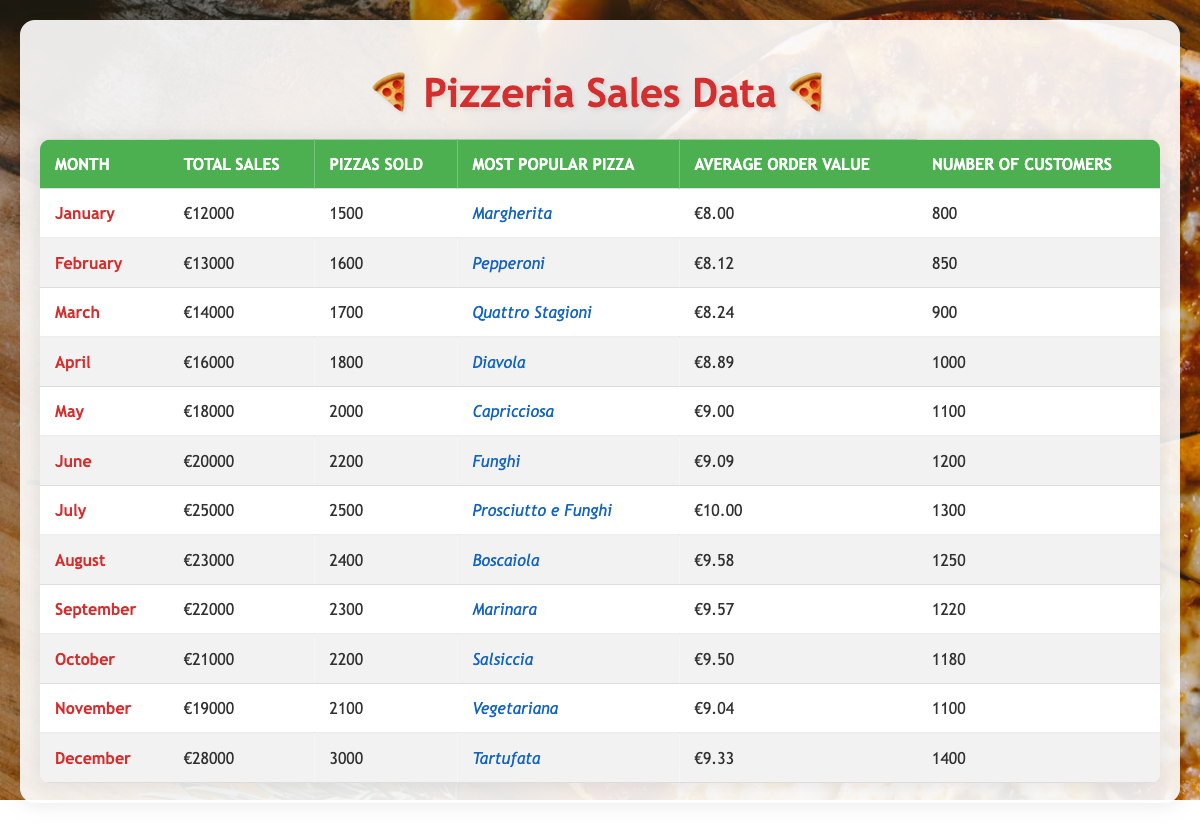What was the total sales in December? The table shows a total sales value of €28,000 for December.
Answer: 28000 Which month had the highest number of pizzas sold? In July, the number of pizzas sold was 2,500, which is the highest compared to other months displayed in the table.
Answer: July What was the average order value in May? The average order value for May is listed as €9.00 in the table.
Answer: 9.00 Is the most popular pizza in January "Margherita"? The table indicates that the most popular pizza sold in January is indeed "Margherita."
Answer: Yes What was the total sales difference between June and July? The total sales in June was €20,000, and in July it was €25,000. The difference is €25,000 - €20,000 = €5,000.
Answer: 5000 Which pizza was the most popular in March and what was its average order value? The most popular pizza in March was "Quattro Stagioni," and its average order value was €8.24, as seen in the table.
Answer: Quattro Stagioni, 8.24 If we average the number of customers from January to March, what would it be? The number of customers from January (800), February (850), and March (900) totals 800 + 850 + 900 = 2550. Dividing by 3 gives an average of 2550/3 = 850.
Answer: 850 What percentage of total sales in December compared to the total sales in January? December's total sales were €28,000 and January's were €12,000. The percentage is calculated as (€28,000 / €12,000) * 100 = 233.33%.
Answer: 233.33% Which month had fewer than 1,000 customers? Looking at the table, both January (800) and February (850) had fewer than 1,000 customers.
Answer: January, February Was the average order value higher in April or March? The average order value in April is €8.89, while in March it is €8.24. Since €8.89 is greater than €8.24, April had a higher average order value.
Answer: April Calculate the total sales for the second half of the year (July to December). Summing the total sales from July (€25,000), August (€23,000), September (€22,000), October (€21,000), November (€19,000), and December (€28,000), we get €25,000 + €23,000 + €22,000 + €21,000 + €19,000 + €28,000 = €138,000.
Answer: 138000 